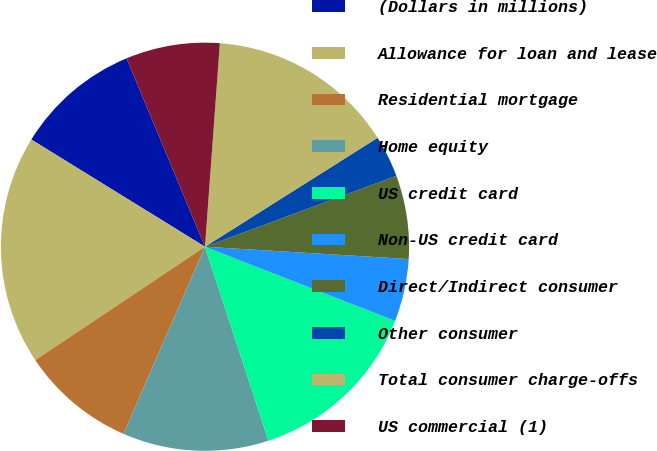Convert chart. <chart><loc_0><loc_0><loc_500><loc_500><pie_chart><fcel>(Dollars in millions)<fcel>Allowance for loan and lease<fcel>Residential mortgage<fcel>Home equity<fcel>US credit card<fcel>Non-US credit card<fcel>Direct/Indirect consumer<fcel>Other consumer<fcel>Total consumer charge-offs<fcel>US commercial (1)<nl><fcel>9.92%<fcel>18.18%<fcel>9.09%<fcel>11.57%<fcel>14.05%<fcel>4.96%<fcel>6.61%<fcel>3.31%<fcel>14.88%<fcel>7.44%<nl></chart> 